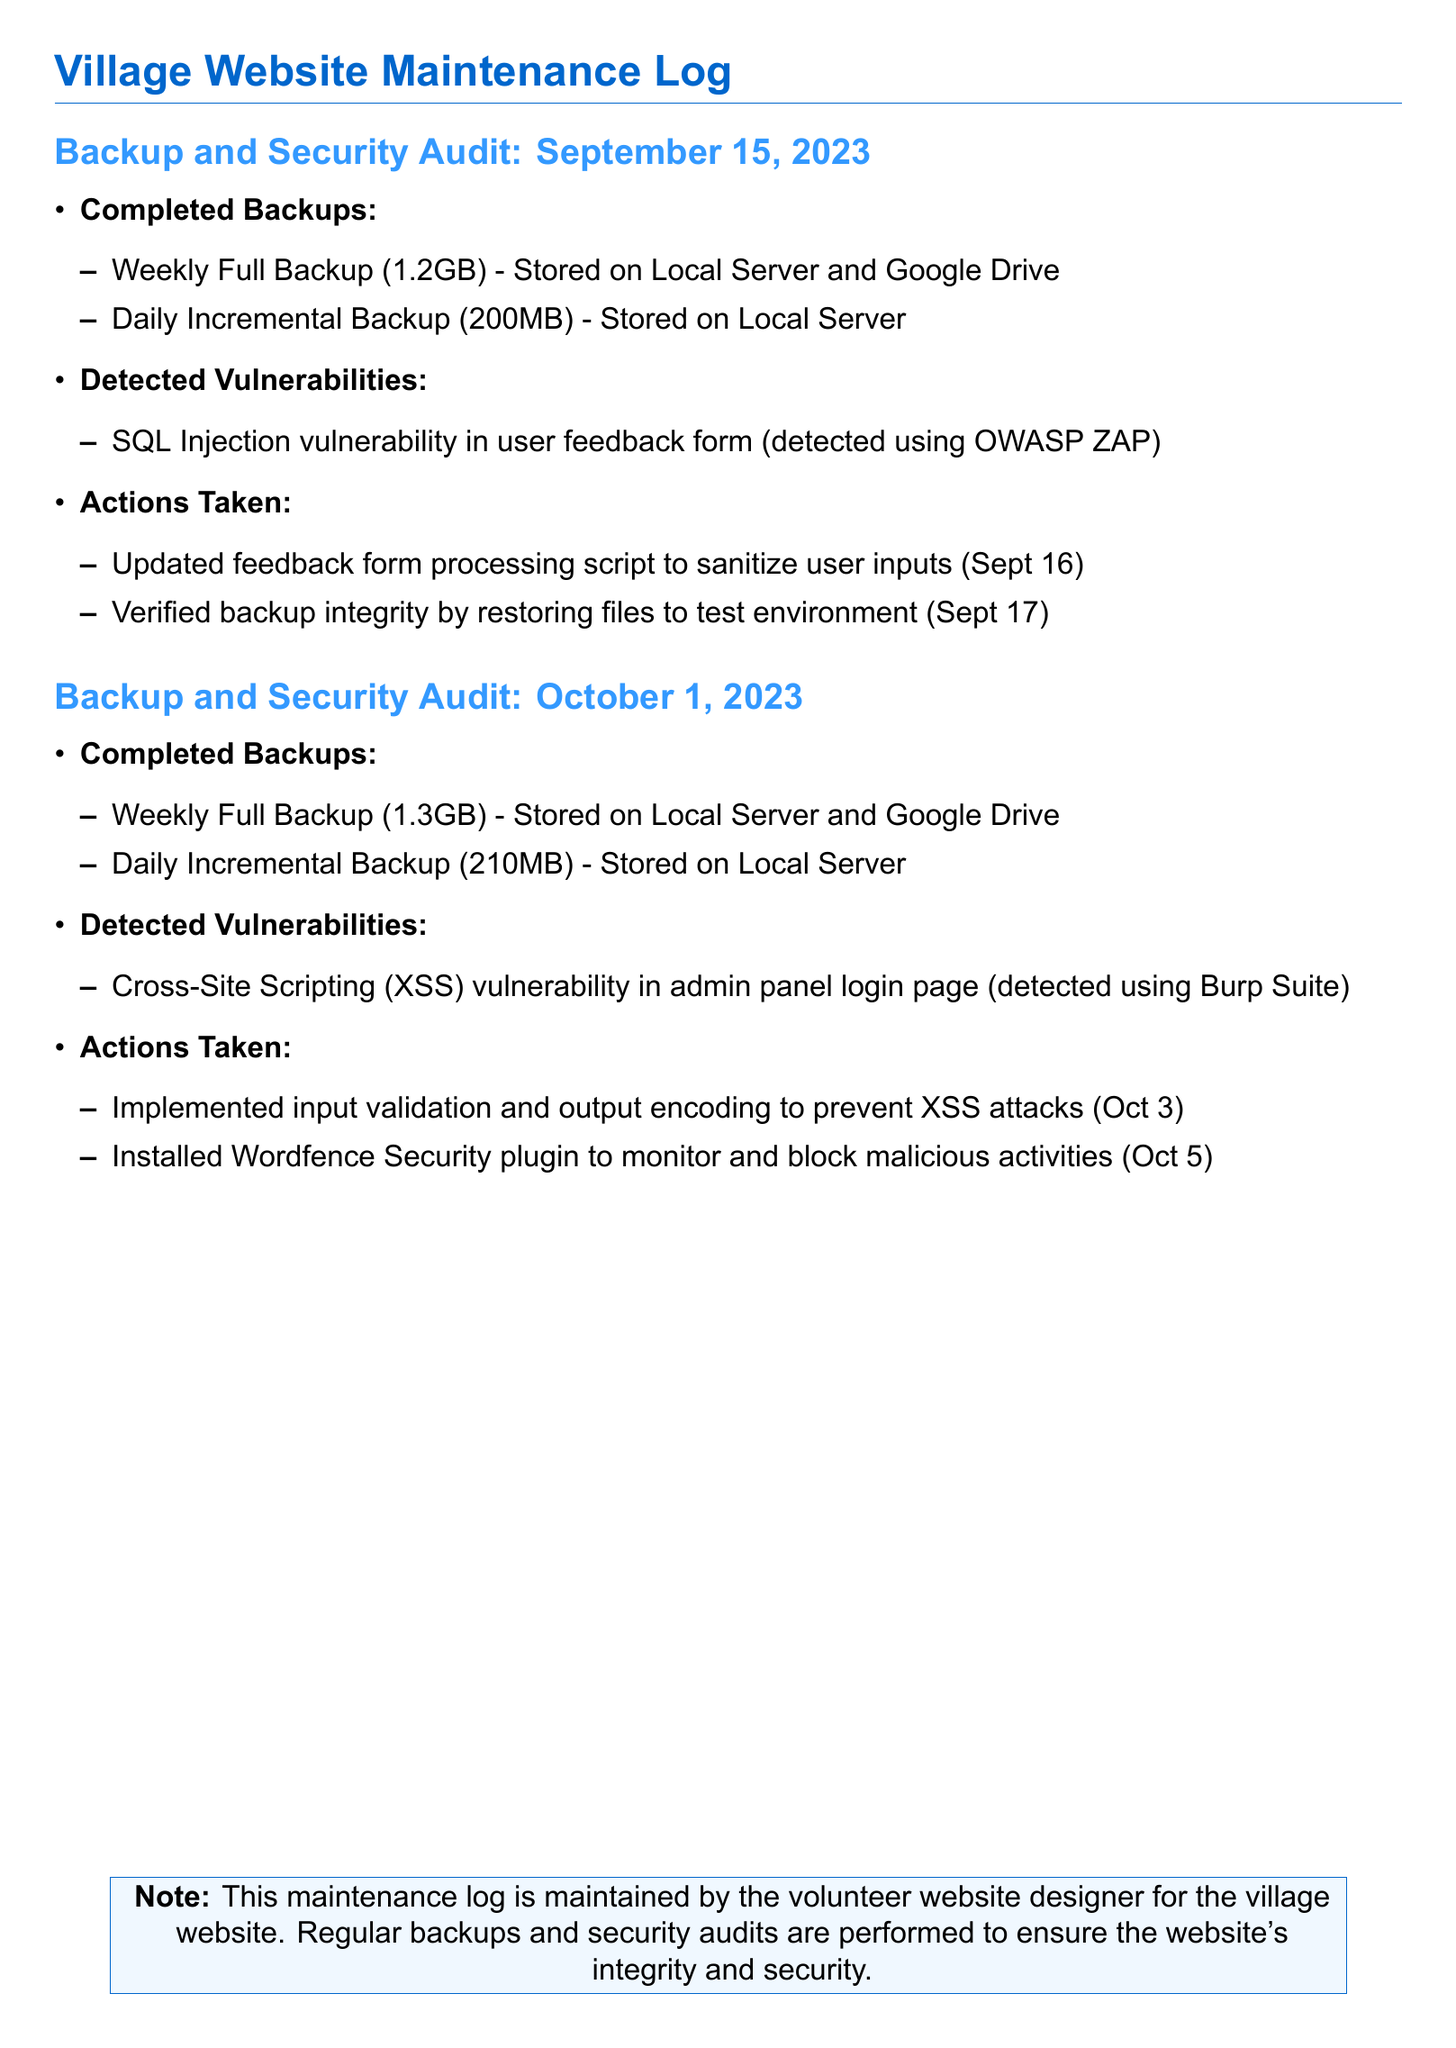What date was the first audit conducted? The first backup and security audit was conducted on September 15, 2023.
Answer: September 15, 2023 How much data was stored in the Weekly Full Backup on October 1, 2023? The Weekly Full Backup on October 1, 2023 was 1.3GB.
Answer: 1.3GB What vulnerability was detected on September 15, 2023? The vulnerability detected on September 15, 2023 was an SQL Injection vulnerability in the user feedback form.
Answer: SQL Injection What action was taken on October 3, 2023? On October 3, 2023, input validation and output encoding were implemented to prevent XSS attacks.
Answer: Input validation and output encoding How many megabytes was the Daily Incremental Backup on October 1, 2023? The Daily Incremental Backup on October 1, 2023 was 210MB.
Answer: 210MB Which security plugin was installed on October 5, 2023? The security plugin installed on October 5, 2023 was the Wordfence Security plugin.
Answer: Wordfence Security plugin What was verified on September 17, 2023? On September 17, 2023, the backup integrity was verified by restoring files to the test environment.
Answer: Backup integrity verified Which tool was used to detect the XSS vulnerability? The tool used to detect the XSS vulnerability was Burp Suite.
Answer: Burp Suite 